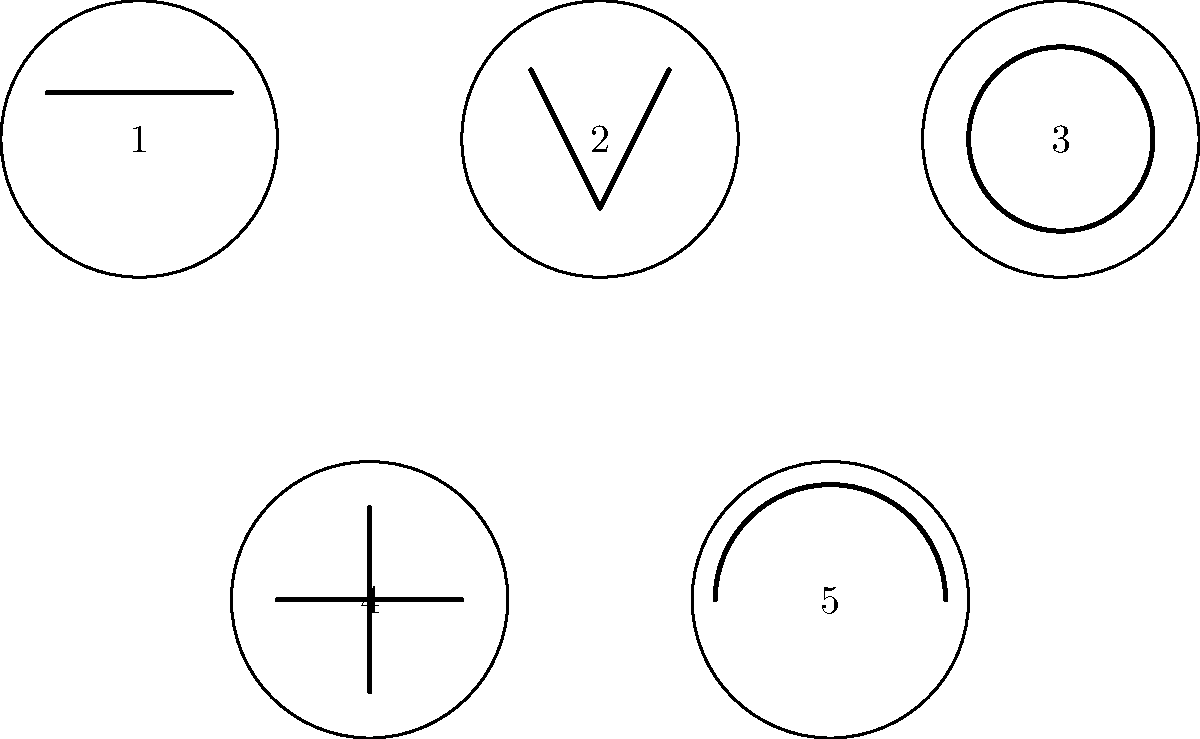As a pageant contestant, you're asked to identify different hairstyles and their cultural significance. Which of the illustrated hairstyles is commonly associated with traditional Japanese culture and often worn by geishas? To answer this question, let's analyze each hairstyle:

1. Style 1: This appears to be a straight, sleek hairstyle with bangs. While popular in many cultures, it's not specifically associated with traditional Japanese culture.

2. Style 2: This represents a triangular or V-shaped hairstyle, which is not typically associated with traditional Japanese styles.

3. Style 3: This illustration shows a round, bun-like hairstyle. This is reminiscent of the traditional Japanese "shimada" hairstyle, often worn by geishas and maikos (apprentice geishas). The shimada is a chignon hairstyle where the hair is gathered together at the back of the head and tied with decorative cords and hairpins.

4. Style 4: This cross-shaped design doesn't represent any specific traditional Japanese hairstyle.

5. Style 5: This half-circle shape could represent various styles but is not distinctively associated with traditional Japanese hairstyles.

The hairstyle most commonly associated with traditional Japanese culture and often worn by geishas is Style 3, the round, bun-like hairstyle representing the shimada. This hairstyle is an integral part of the geisha's appearance and holds significant cultural importance in Japanese tradition.
Answer: Style 3 (the round, bun-like hairstyle) 